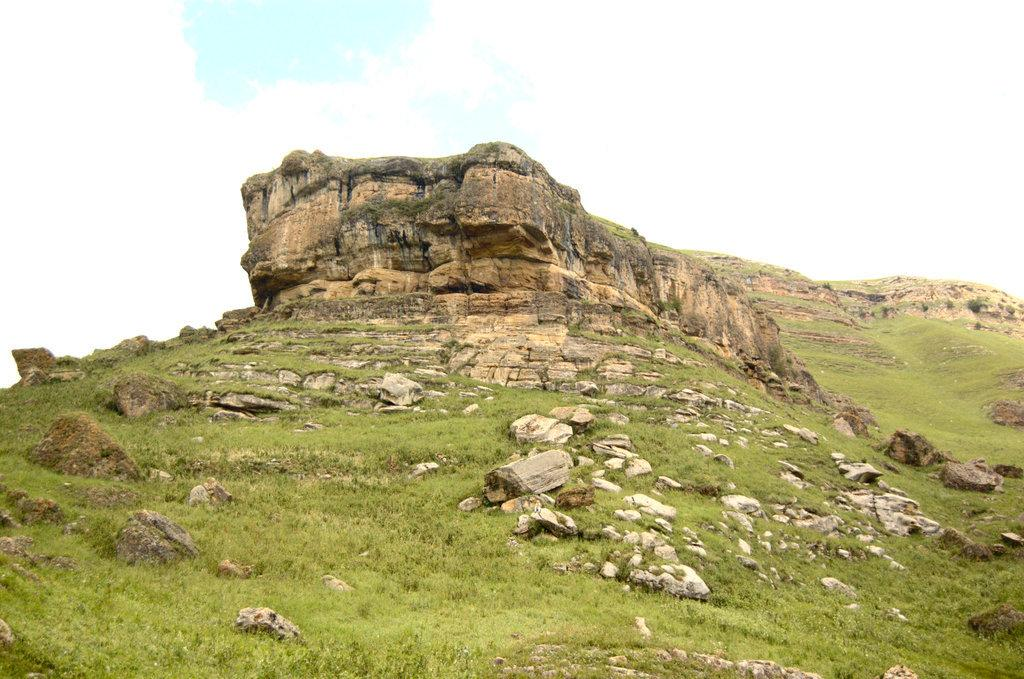What is the main subject in the center of the image? There is a mountain in the center of the image. What type of terrain is visible in the image? There are stones and grass visible in the image. What is visible at the top of the image? The sky is visible at the top of the image. What type of mitten is being used to hold the wire in the image? There is no mitten or wire present in the image. What type of coat is being worn by the person standing on the grass in the image? There is no person or coat present in the image. 